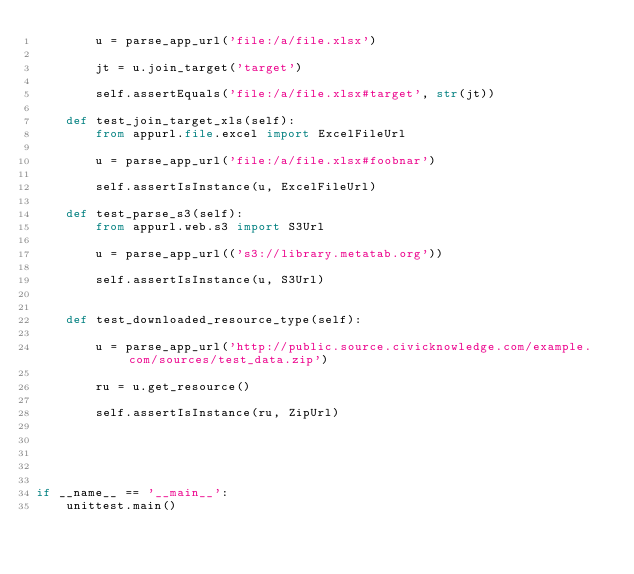Convert code to text. <code><loc_0><loc_0><loc_500><loc_500><_Python_>        u = parse_app_url('file:/a/file.xlsx')

        jt = u.join_target('target')

        self.assertEquals('file:/a/file.xlsx#target', str(jt))

    def test_join_target_xls(self):
        from appurl.file.excel import ExcelFileUrl

        u = parse_app_url('file:/a/file.xlsx#foobnar')

        self.assertIsInstance(u, ExcelFileUrl)

    def test_parse_s3(self):
        from appurl.web.s3 import S3Url

        u = parse_app_url(('s3://library.metatab.org'))

        self.assertIsInstance(u, S3Url)


    def test_downloaded_resource_type(self):

        u = parse_app_url('http://public.source.civicknowledge.com/example.com/sources/test_data.zip')

        ru = u.get_resource()

        self.assertIsInstance(ru, ZipUrl)





if __name__ == '__main__':
    unittest.main()</code> 